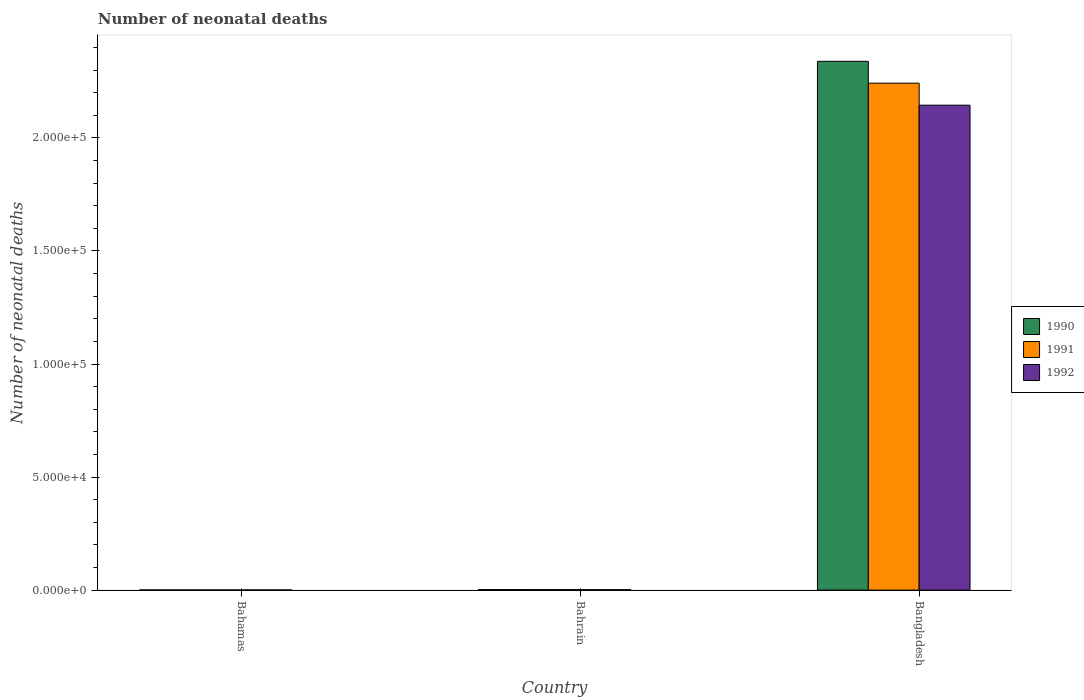How many groups of bars are there?
Your answer should be compact. 3. Are the number of bars per tick equal to the number of legend labels?
Provide a short and direct response. Yes. Are the number of bars on each tick of the X-axis equal?
Keep it short and to the point. Yes. How many bars are there on the 1st tick from the left?
Give a very brief answer. 3. How many bars are there on the 3rd tick from the right?
Provide a short and direct response. 3. What is the label of the 3rd group of bars from the left?
Give a very brief answer. Bangladesh. In how many cases, is the number of bars for a given country not equal to the number of legend labels?
Offer a very short reply. 0. What is the number of neonatal deaths in in 1990 in Bahamas?
Offer a terse response. 72. Across all countries, what is the maximum number of neonatal deaths in in 1992?
Your response must be concise. 2.14e+05. Across all countries, what is the minimum number of neonatal deaths in in 1990?
Provide a short and direct response. 72. In which country was the number of neonatal deaths in in 1990 maximum?
Offer a terse response. Bangladesh. In which country was the number of neonatal deaths in in 1991 minimum?
Ensure brevity in your answer.  Bahamas. What is the total number of neonatal deaths in in 1990 in the graph?
Provide a succinct answer. 2.34e+05. What is the difference between the number of neonatal deaths in in 1992 in Bahamas and that in Bahrain?
Provide a short and direct response. -116. What is the difference between the number of neonatal deaths in in 1990 in Bahrain and the number of neonatal deaths in in 1991 in Bangladesh?
Your answer should be very brief. -2.24e+05. What is the average number of neonatal deaths in in 1990 per country?
Provide a succinct answer. 7.81e+04. What is the difference between the number of neonatal deaths in of/in 1992 and number of neonatal deaths in of/in 1990 in Bangladesh?
Provide a succinct answer. -1.94e+04. In how many countries, is the number of neonatal deaths in in 1991 greater than 160000?
Provide a succinct answer. 1. What is the ratio of the number of neonatal deaths in in 1990 in Bahamas to that in Bahrain?
Keep it short and to the point. 0.32. Is the difference between the number of neonatal deaths in in 1992 in Bahamas and Bangladesh greater than the difference between the number of neonatal deaths in in 1990 in Bahamas and Bangladesh?
Keep it short and to the point. Yes. What is the difference between the highest and the second highest number of neonatal deaths in in 1991?
Give a very brief answer. -2.24e+05. What is the difference between the highest and the lowest number of neonatal deaths in in 1990?
Your answer should be compact. 2.34e+05. In how many countries, is the number of neonatal deaths in in 1990 greater than the average number of neonatal deaths in in 1990 taken over all countries?
Your response must be concise. 1. Is the sum of the number of neonatal deaths in in 1990 in Bahamas and Bangladesh greater than the maximum number of neonatal deaths in in 1991 across all countries?
Keep it short and to the point. Yes. What does the 1st bar from the left in Bangladesh represents?
Give a very brief answer. 1990. What does the 3rd bar from the right in Bahrain represents?
Ensure brevity in your answer.  1990. Are all the bars in the graph horizontal?
Give a very brief answer. No. How many countries are there in the graph?
Offer a very short reply. 3. Are the values on the major ticks of Y-axis written in scientific E-notation?
Provide a short and direct response. Yes. Does the graph contain any zero values?
Provide a short and direct response. No. Does the graph contain grids?
Provide a succinct answer. No. How are the legend labels stacked?
Provide a succinct answer. Vertical. What is the title of the graph?
Give a very brief answer. Number of neonatal deaths. Does "1990" appear as one of the legend labels in the graph?
Keep it short and to the point. Yes. What is the label or title of the X-axis?
Your response must be concise. Country. What is the label or title of the Y-axis?
Offer a terse response. Number of neonatal deaths. What is the Number of neonatal deaths in 1991 in Bahamas?
Offer a very short reply. 71. What is the Number of neonatal deaths in 1992 in Bahamas?
Your answer should be very brief. 72. What is the Number of neonatal deaths in 1990 in Bahrain?
Ensure brevity in your answer.  222. What is the Number of neonatal deaths in 1991 in Bahrain?
Make the answer very short. 208. What is the Number of neonatal deaths of 1992 in Bahrain?
Ensure brevity in your answer.  188. What is the Number of neonatal deaths in 1990 in Bangladesh?
Offer a very short reply. 2.34e+05. What is the Number of neonatal deaths of 1991 in Bangladesh?
Your answer should be very brief. 2.24e+05. What is the Number of neonatal deaths in 1992 in Bangladesh?
Your answer should be very brief. 2.14e+05. Across all countries, what is the maximum Number of neonatal deaths of 1990?
Keep it short and to the point. 2.34e+05. Across all countries, what is the maximum Number of neonatal deaths in 1991?
Your response must be concise. 2.24e+05. Across all countries, what is the maximum Number of neonatal deaths of 1992?
Provide a succinct answer. 2.14e+05. Across all countries, what is the minimum Number of neonatal deaths of 1990?
Your answer should be compact. 72. What is the total Number of neonatal deaths in 1990 in the graph?
Provide a succinct answer. 2.34e+05. What is the total Number of neonatal deaths of 1991 in the graph?
Offer a terse response. 2.25e+05. What is the total Number of neonatal deaths in 1992 in the graph?
Make the answer very short. 2.15e+05. What is the difference between the Number of neonatal deaths in 1990 in Bahamas and that in Bahrain?
Your answer should be very brief. -150. What is the difference between the Number of neonatal deaths in 1991 in Bahamas and that in Bahrain?
Offer a terse response. -137. What is the difference between the Number of neonatal deaths of 1992 in Bahamas and that in Bahrain?
Your answer should be compact. -116. What is the difference between the Number of neonatal deaths in 1990 in Bahamas and that in Bangladesh?
Make the answer very short. -2.34e+05. What is the difference between the Number of neonatal deaths in 1991 in Bahamas and that in Bangladesh?
Provide a short and direct response. -2.24e+05. What is the difference between the Number of neonatal deaths in 1992 in Bahamas and that in Bangladesh?
Provide a short and direct response. -2.14e+05. What is the difference between the Number of neonatal deaths of 1990 in Bahrain and that in Bangladesh?
Offer a very short reply. -2.34e+05. What is the difference between the Number of neonatal deaths in 1991 in Bahrain and that in Bangladesh?
Give a very brief answer. -2.24e+05. What is the difference between the Number of neonatal deaths in 1992 in Bahrain and that in Bangladesh?
Offer a terse response. -2.14e+05. What is the difference between the Number of neonatal deaths of 1990 in Bahamas and the Number of neonatal deaths of 1991 in Bahrain?
Your response must be concise. -136. What is the difference between the Number of neonatal deaths in 1990 in Bahamas and the Number of neonatal deaths in 1992 in Bahrain?
Ensure brevity in your answer.  -116. What is the difference between the Number of neonatal deaths of 1991 in Bahamas and the Number of neonatal deaths of 1992 in Bahrain?
Provide a succinct answer. -117. What is the difference between the Number of neonatal deaths in 1990 in Bahamas and the Number of neonatal deaths in 1991 in Bangladesh?
Your response must be concise. -2.24e+05. What is the difference between the Number of neonatal deaths in 1990 in Bahamas and the Number of neonatal deaths in 1992 in Bangladesh?
Give a very brief answer. -2.14e+05. What is the difference between the Number of neonatal deaths of 1991 in Bahamas and the Number of neonatal deaths of 1992 in Bangladesh?
Provide a short and direct response. -2.14e+05. What is the difference between the Number of neonatal deaths of 1990 in Bahrain and the Number of neonatal deaths of 1991 in Bangladesh?
Provide a succinct answer. -2.24e+05. What is the difference between the Number of neonatal deaths in 1990 in Bahrain and the Number of neonatal deaths in 1992 in Bangladesh?
Provide a succinct answer. -2.14e+05. What is the difference between the Number of neonatal deaths of 1991 in Bahrain and the Number of neonatal deaths of 1992 in Bangladesh?
Offer a terse response. -2.14e+05. What is the average Number of neonatal deaths in 1990 per country?
Offer a terse response. 7.81e+04. What is the average Number of neonatal deaths in 1991 per country?
Your answer should be compact. 7.48e+04. What is the average Number of neonatal deaths of 1992 per country?
Your answer should be compact. 7.16e+04. What is the difference between the Number of neonatal deaths of 1990 and Number of neonatal deaths of 1992 in Bahamas?
Make the answer very short. 0. What is the difference between the Number of neonatal deaths in 1990 and Number of neonatal deaths in 1991 in Bangladesh?
Ensure brevity in your answer.  9655. What is the difference between the Number of neonatal deaths of 1990 and Number of neonatal deaths of 1992 in Bangladesh?
Ensure brevity in your answer.  1.94e+04. What is the difference between the Number of neonatal deaths of 1991 and Number of neonatal deaths of 1992 in Bangladesh?
Your answer should be very brief. 9749. What is the ratio of the Number of neonatal deaths of 1990 in Bahamas to that in Bahrain?
Keep it short and to the point. 0.32. What is the ratio of the Number of neonatal deaths of 1991 in Bahamas to that in Bahrain?
Provide a short and direct response. 0.34. What is the ratio of the Number of neonatal deaths in 1992 in Bahamas to that in Bahrain?
Your answer should be compact. 0.38. What is the ratio of the Number of neonatal deaths of 1990 in Bahamas to that in Bangladesh?
Provide a short and direct response. 0. What is the ratio of the Number of neonatal deaths of 1991 in Bahamas to that in Bangladesh?
Your answer should be very brief. 0. What is the ratio of the Number of neonatal deaths of 1992 in Bahamas to that in Bangladesh?
Ensure brevity in your answer.  0. What is the ratio of the Number of neonatal deaths of 1990 in Bahrain to that in Bangladesh?
Give a very brief answer. 0. What is the ratio of the Number of neonatal deaths in 1991 in Bahrain to that in Bangladesh?
Provide a short and direct response. 0. What is the ratio of the Number of neonatal deaths of 1992 in Bahrain to that in Bangladesh?
Your response must be concise. 0. What is the difference between the highest and the second highest Number of neonatal deaths in 1990?
Your response must be concise. 2.34e+05. What is the difference between the highest and the second highest Number of neonatal deaths in 1991?
Your answer should be compact. 2.24e+05. What is the difference between the highest and the second highest Number of neonatal deaths in 1992?
Offer a terse response. 2.14e+05. What is the difference between the highest and the lowest Number of neonatal deaths of 1990?
Your answer should be compact. 2.34e+05. What is the difference between the highest and the lowest Number of neonatal deaths in 1991?
Offer a very short reply. 2.24e+05. What is the difference between the highest and the lowest Number of neonatal deaths in 1992?
Your answer should be very brief. 2.14e+05. 